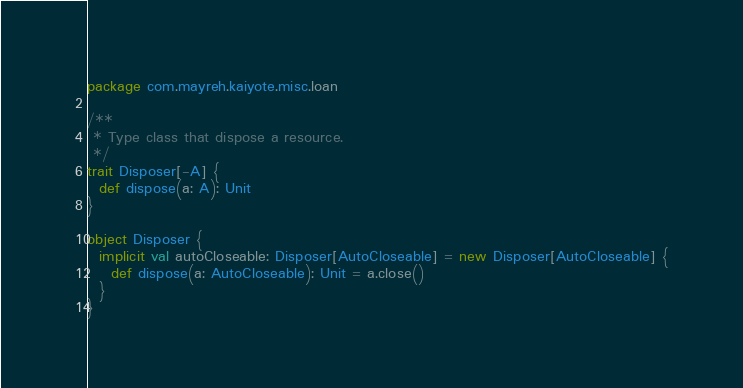Convert code to text. <code><loc_0><loc_0><loc_500><loc_500><_Scala_>package com.mayreh.kaiyote.misc.loan

/**
 * Type class that dispose a resource.
 */
trait Disposer[-A] {
  def dispose(a: A): Unit
}

object Disposer {
  implicit val autoCloseable: Disposer[AutoCloseable] = new Disposer[AutoCloseable] {
    def dispose(a: AutoCloseable): Unit = a.close()
  }
}
</code> 